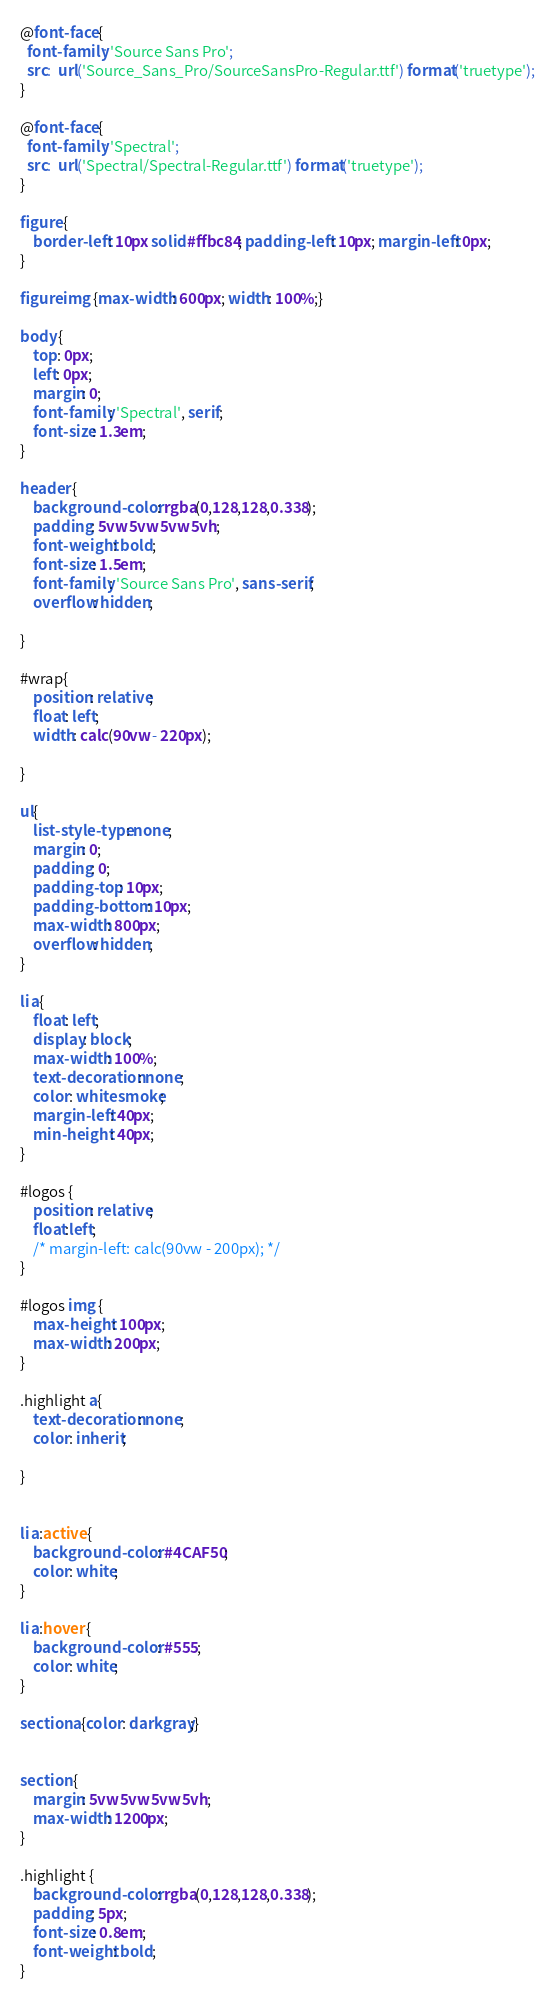Convert code to text. <code><loc_0><loc_0><loc_500><loc_500><_CSS_>@font-face {
  font-family: 'Source Sans Pro';
  src:  url('Source_Sans_Pro/SourceSansPro-Regular.ttf') format('truetype');
}

@font-face {
  font-family: 'Spectral';
  src:  url('Spectral/Spectral-Regular.ttf') format('truetype');
}

figure {
    border-left: 10px solid #ffbc84; padding-left: 10px; margin-left: 0px;
}

figure img {max-width: 600px; width: 100%;}

body {
    top: 0px;
    left: 0px;    
    margin: 0;
    font-family: 'Spectral', serif;
    font-size: 1.3em;
}

header {
    background-color: rgba(0,128,128,0.338);
    padding: 5vw 5vw 5vw 5vh;
    font-weight: bold;
    font-size: 1.5em;
    font-family: 'Source Sans Pro', sans-serif;
    overflow: hidden;

}

#wrap{ 
    position: relative;
    float: left;
    width: calc(90vw - 220px);

}

ul{
    list-style-type: none;
    margin: 0;
    padding: 0;
    padding-top: 10px;
    padding-bottom: 10px;
    max-width: 800px;
    overflow: hidden;
}

li a{
    float: left;
    display: block;
    max-width: 100%;
    text-decoration: none;
    color: whitesmoke;
    margin-left: 40px;
    min-height: 40px;
}

#logos {
    position: relative;
    float:left;  
    /* margin-left: calc(90vw - 200px); */
}

#logos img {
    max-height: 100px;
    max-width: 200px;
}

.highlight a{
    text-decoration: none;
    color: inherit;
    
}


li a:active {
    background-color: #4CAF50;
    color: white;
}

li a:hover {
    background-color: #555;
    color: white;
}

section a{color: darkgray;}


section {
    margin: 5vw 5vw 5vw 5vh;
    max-width: 1200px;
}

.highlight {
    background-color: rgba(0,128,128,0.338);
    padding: 5px;
    font-size: 0.8em;
    font-weight: bold;
}</code> 